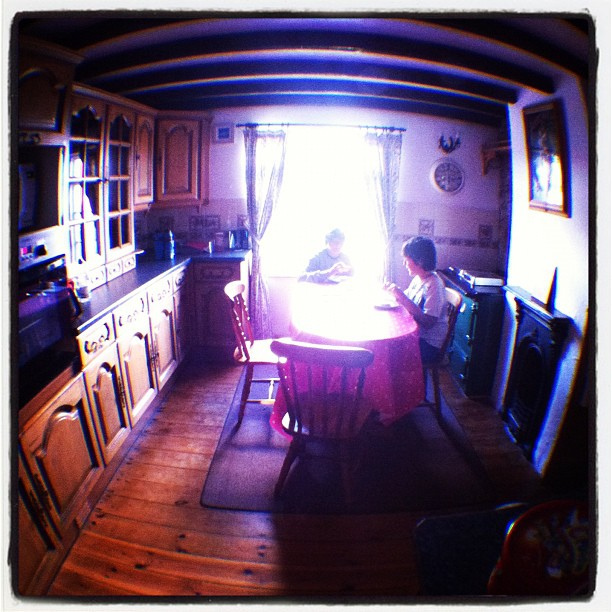How many chairs are visible? There are four chairs visible around the table, each exhibiting a classic design that complements the rustic aesthetic of the kitchen interior. 